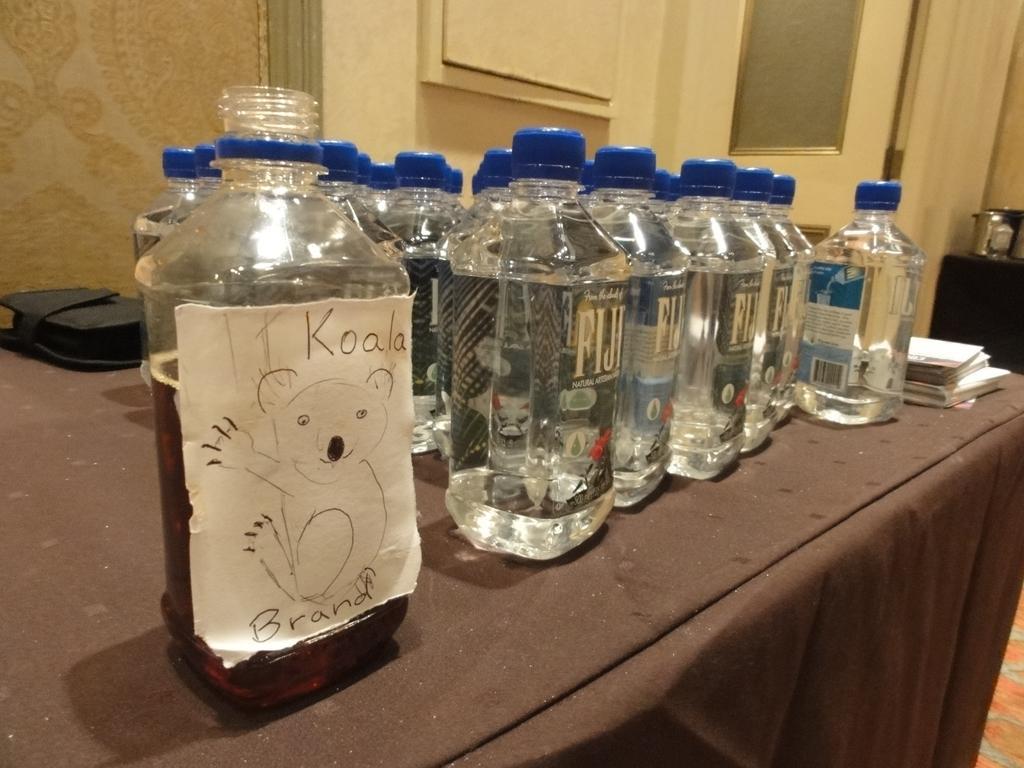Can you describe this image briefly? This picture shows a bunch of water bottles on the table 